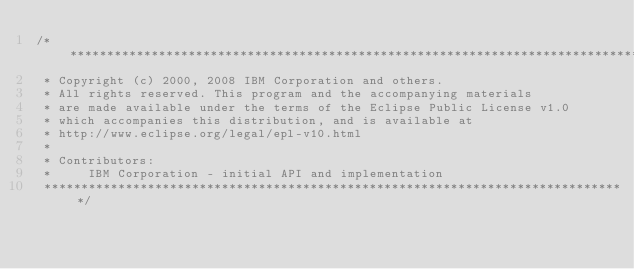Convert code to text. <code><loc_0><loc_0><loc_500><loc_500><_Java_>/*******************************************************************************
 * Copyright (c) 2000, 2008 IBM Corporation and others.
 * All rights reserved. This program and the accompanying materials
 * are made available under the terms of the Eclipse Public License v1.0
 * which accompanies this distribution, and is available at
 * http://www.eclipse.org/legal/epl-v10.html
 *
 * Contributors:
 *     IBM Corporation - initial API and implementation
 *******************************************************************************/</code> 